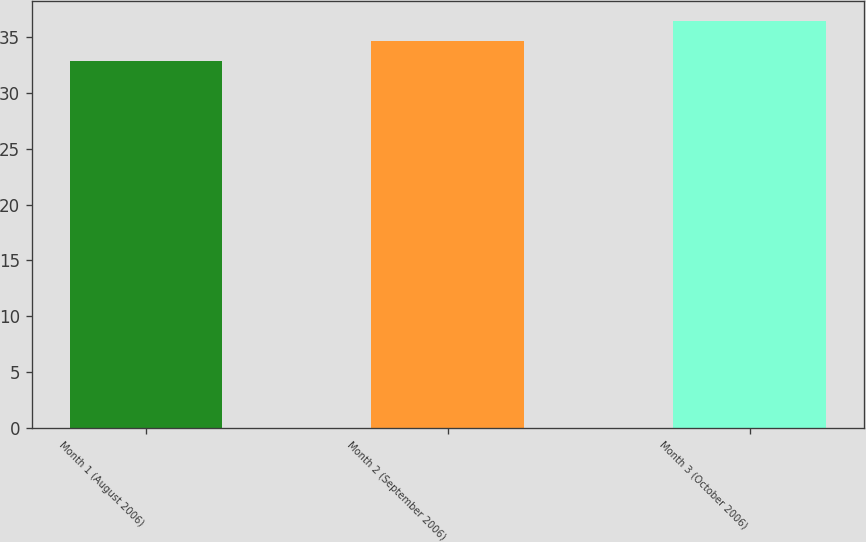<chart> <loc_0><loc_0><loc_500><loc_500><bar_chart><fcel>Month 1 (August 2006)<fcel>Month 2 (September 2006)<fcel>Month 3 (October 2006)<nl><fcel>32.85<fcel>34.65<fcel>36.39<nl></chart> 